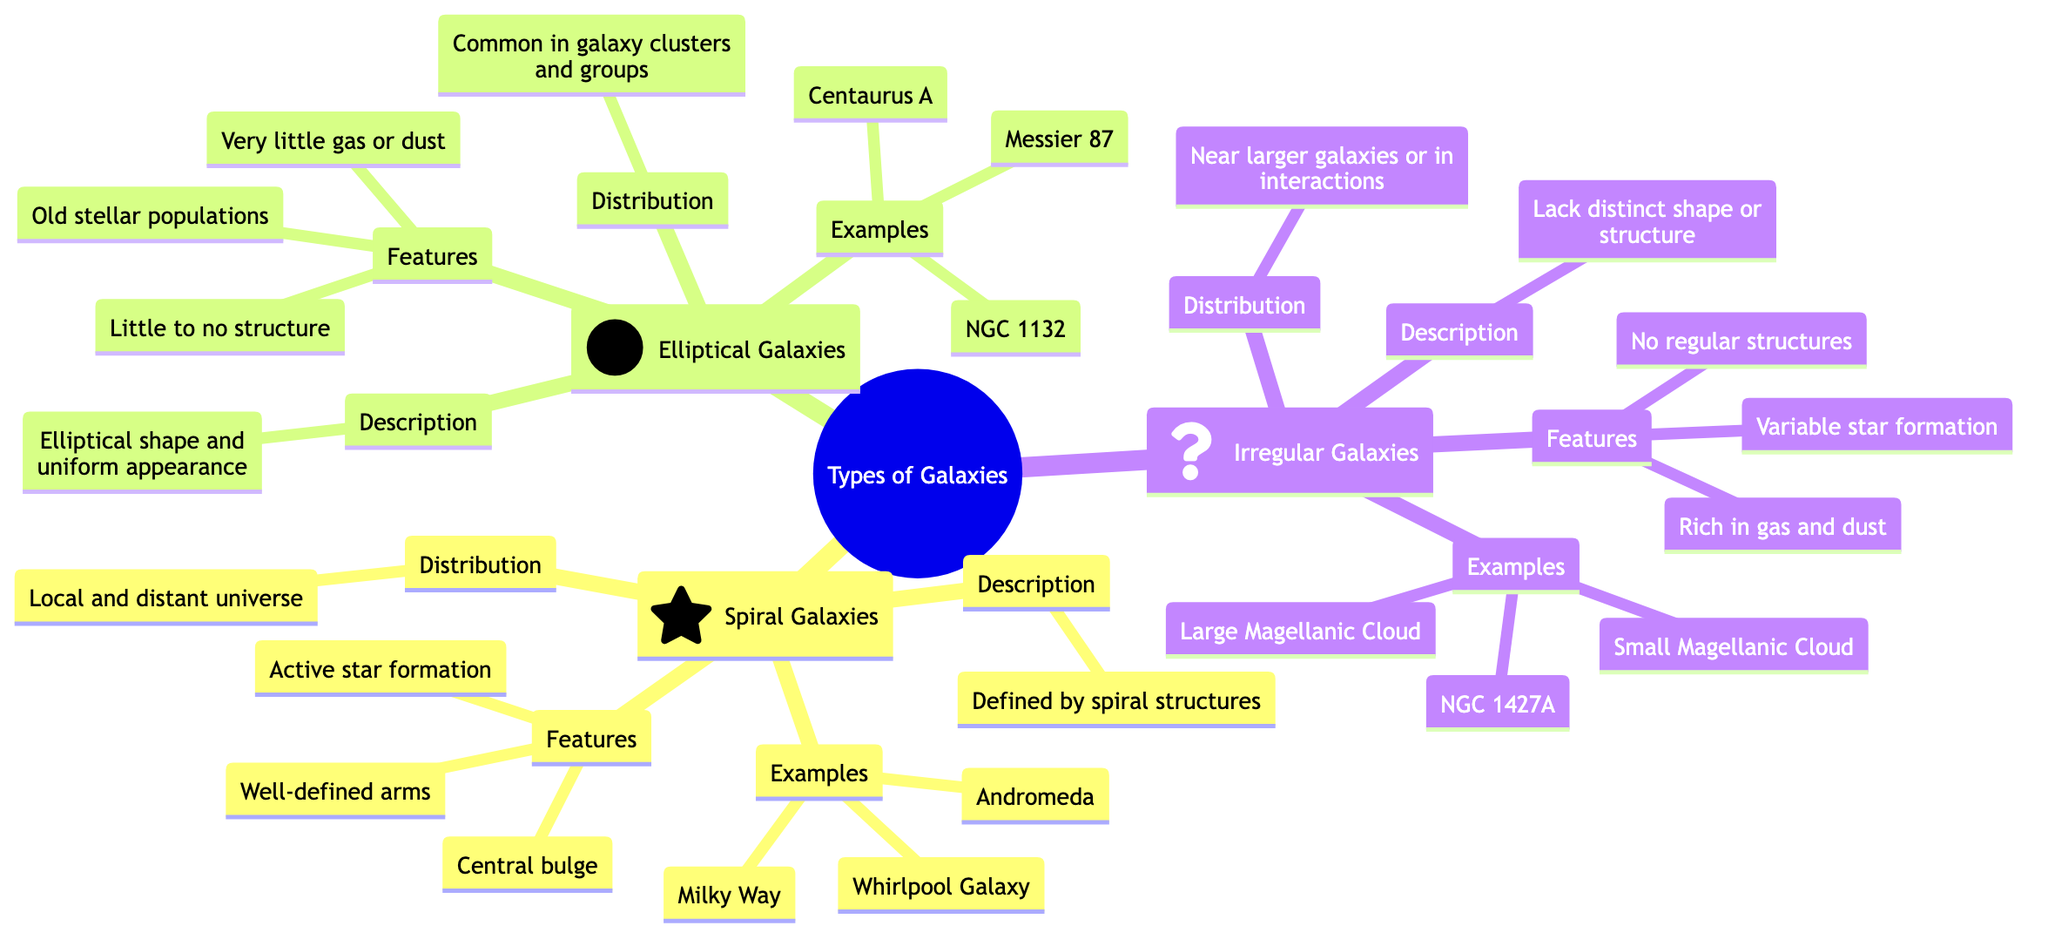What are the three types of galaxies mentioned in the diagram? The diagram categorizes galaxies into three types: Spiral, Elliptical, and Irregular. Each type is a main branch of the diagram, clearly labeled with its respective name.
Answer: Spiral, Elliptical, Irregular Which galaxy is an example of a Spiral galaxy? The diagram lists examples under each type of galaxy. For Spiral galaxies, Milky Way is first mentioned as an example.
Answer: Milky Way What feature distinguishes Elliptical galaxies from Spiral galaxies? In the Features section for Elliptical galaxies, it states "Little to no structure," while Spiral galaxies have "Well-defined arms." This contrast highlights a key difference.
Answer: Little to no structure How many examples are listed for Irregular galaxies? Referring to the Examples section for Irregular galaxies, there are three specific examples: Large Magellanic Cloud, Small Magellanic Cloud, and NGC 1427A. This count gives the answer.
Answer: Three In what distribution are Elliptical galaxies commonly found? The Distribution section for Elliptical galaxies notes they are "Common in galaxy clusters and groups." This direct reference provides the answer.
Answer: Common in galaxy clusters and groups What type of galaxy has an active star formation feature? The Features section for Spiral galaxies notes "Active star formation." This indicates that this feature is specific to Spiral galaxies compared to the others.
Answer: Spiral Which galaxy is an example of an Elliptical galaxy? Looking under the Examples of Elliptical galaxies, Messier 87 is explicitly mentioned as one of the examples.
Answer: Messier 87 What is a characteristic feature of Irregular galaxies? From the Features section, Irregular galaxies are described with "No regular structures," which highlights their defining feature.
Answer: No regular structures How many distinct features are listed for Spiral galaxies? In the Features section for Spiral galaxies, there are three features mentioned: "Well-defined arms," "Central bulge," and "Active star formation." Counting these gives the answer.
Answer: Three 